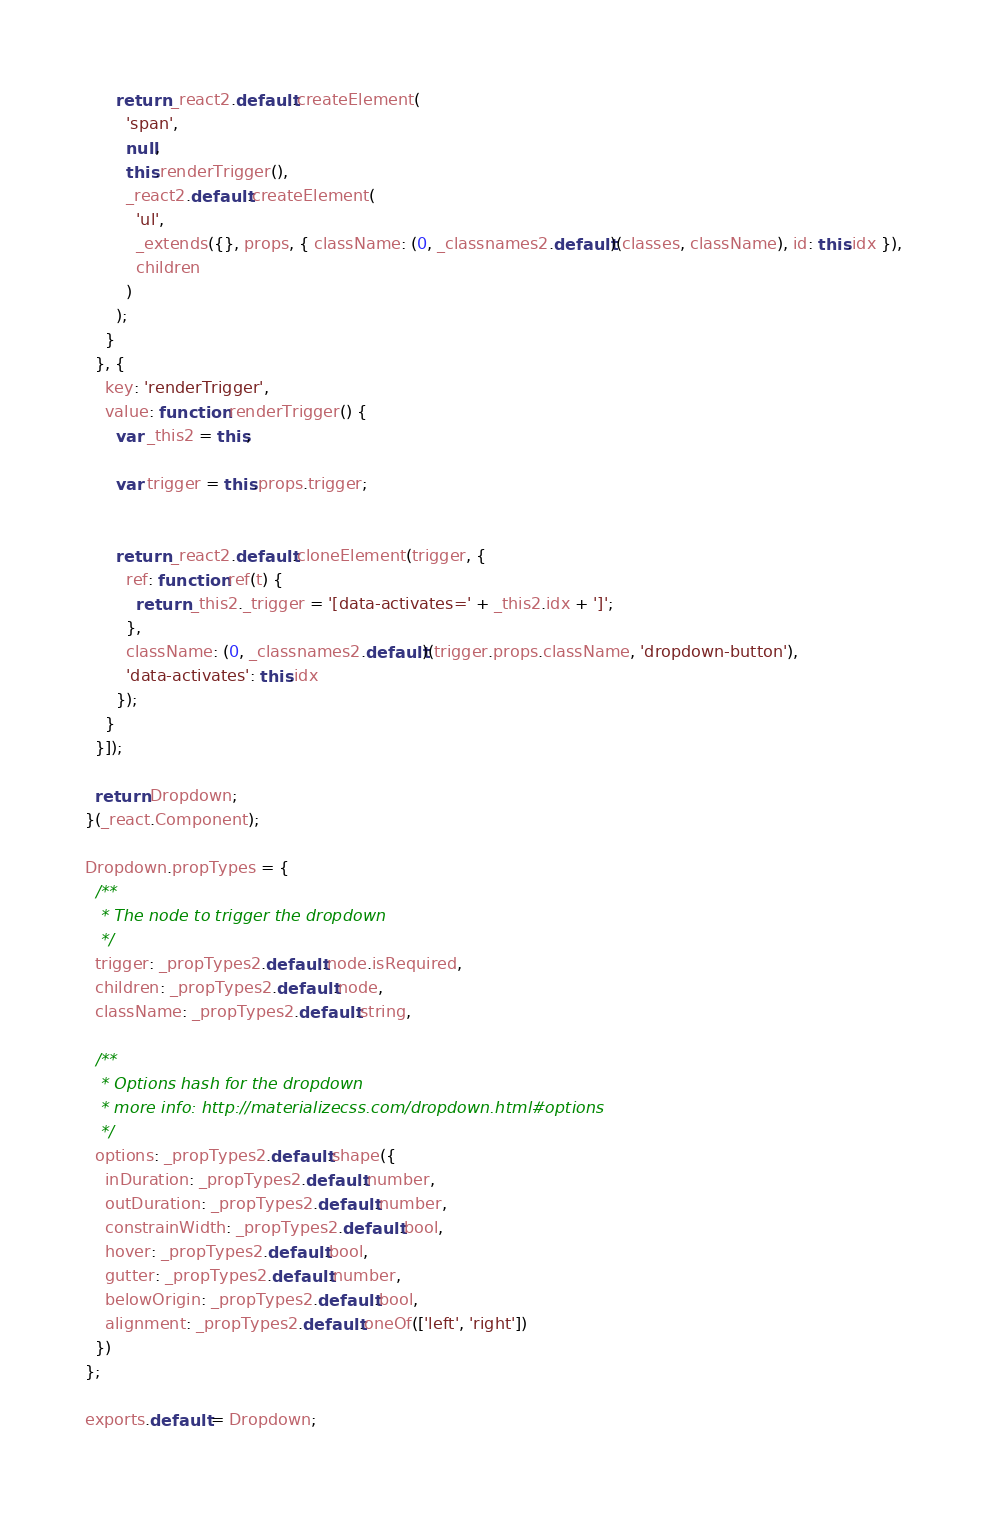<code> <loc_0><loc_0><loc_500><loc_500><_JavaScript_>      return _react2.default.createElement(
        'span',
        null,
        this.renderTrigger(),
        _react2.default.createElement(
          'ul',
          _extends({}, props, { className: (0, _classnames2.default)(classes, className), id: this.idx }),
          children
        )
      );
    }
  }, {
    key: 'renderTrigger',
    value: function renderTrigger() {
      var _this2 = this;

      var trigger = this.props.trigger;


      return _react2.default.cloneElement(trigger, {
        ref: function ref(t) {
          return _this2._trigger = '[data-activates=' + _this2.idx + ']';
        },
        className: (0, _classnames2.default)(trigger.props.className, 'dropdown-button'),
        'data-activates': this.idx
      });
    }
  }]);

  return Dropdown;
}(_react.Component);

Dropdown.propTypes = {
  /**
   * The node to trigger the dropdown
   */
  trigger: _propTypes2.default.node.isRequired,
  children: _propTypes2.default.node,
  className: _propTypes2.default.string,

  /**
   * Options hash for the dropdown
   * more info: http://materializecss.com/dropdown.html#options
   */
  options: _propTypes2.default.shape({
    inDuration: _propTypes2.default.number,
    outDuration: _propTypes2.default.number,
    constrainWidth: _propTypes2.default.bool,
    hover: _propTypes2.default.bool,
    gutter: _propTypes2.default.number,
    belowOrigin: _propTypes2.default.bool,
    alignment: _propTypes2.default.oneOf(['left', 'right'])
  })
};

exports.default = Dropdown;</code> 